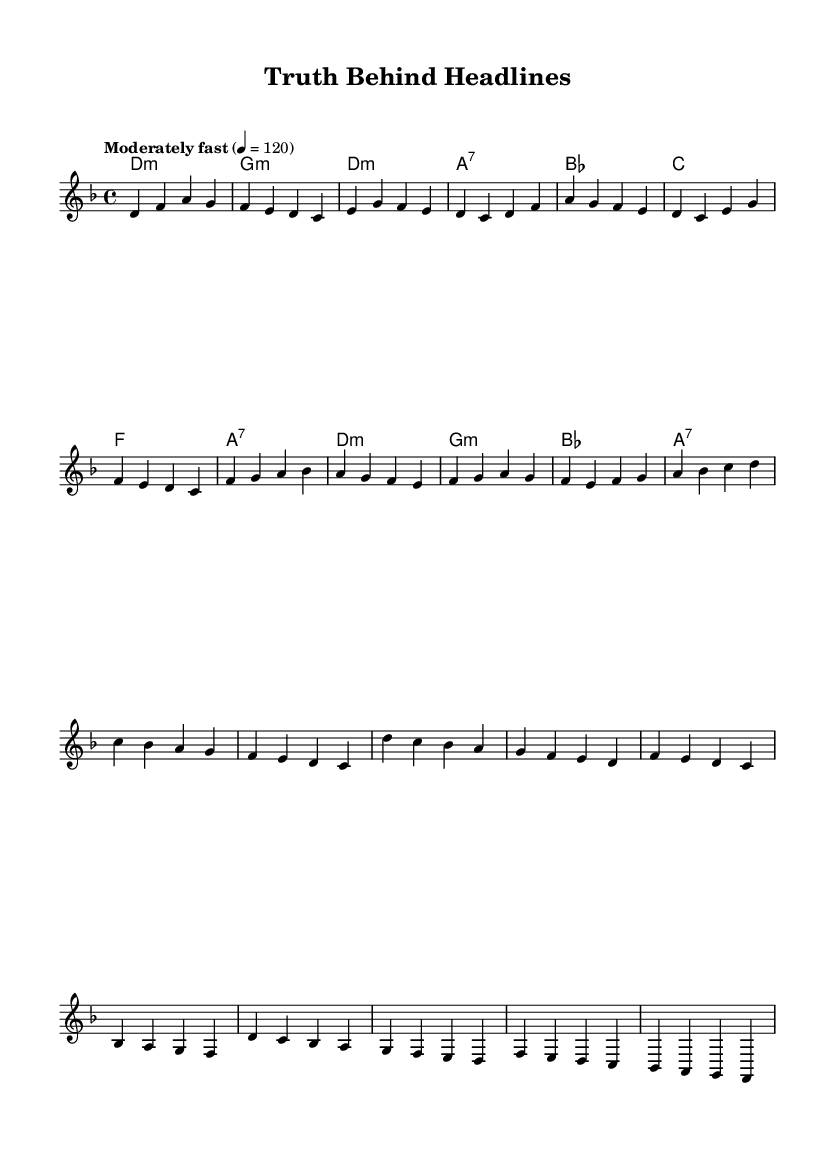What is the key signature of this music? The key signature indicated in the global settings shows that it is in D minor, which has one flat (B flat).
Answer: D minor What is the time signature of this music? The time signature specified is 4/4, meaning there are four beats in each measure and a quarter note gets one beat.
Answer: 4/4 What is the tempo marking for this piece? The tempo is denoted as "Moderately fast" with a metronome marking of quarter note equals 120 beats per minute, indicating a brisk tempo.
Answer: Moderately fast How many measures are in the verse section? The verse section consists of two lines of melody, each containing four measures, totaling 8 measures overall.
Answer: 8 What is the chord progression of the pre-chorus? The chords in the pre-chorus follow the sequence: B flat, C, F, and A7. This reflects the harmonic changes that accompany the melody during that section.
Answer: B flat, C, F, A7 How does the melody change from the verse to the chorus? The melody transitions from a sequential flow in the verse to a more dynamic and descending contour in the chorus, creating an emotional peak. This indicates a shift in musical tension and resolution.
Answer: More dynamic and descending What is a prominent theme addressed in this song? The song's lyrics reflect themes of truth and the impact of sensational media, which aligns with K-Pop's trend of engaging with social issues.
Answer: Truth and media sensationalism 